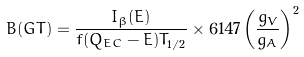<formula> <loc_0><loc_0><loc_500><loc_500>B ( G T ) = \frac { I _ { \beta } ( E ) } { f ( Q _ { E C } - E ) T _ { 1 / 2 } } \times 6 1 4 7 \left ( \frac { g _ { V } } { g _ { A } } \right ) ^ { 2 }</formula> 